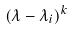<formula> <loc_0><loc_0><loc_500><loc_500>( \lambda - \lambda _ { i } ) ^ { k }</formula> 